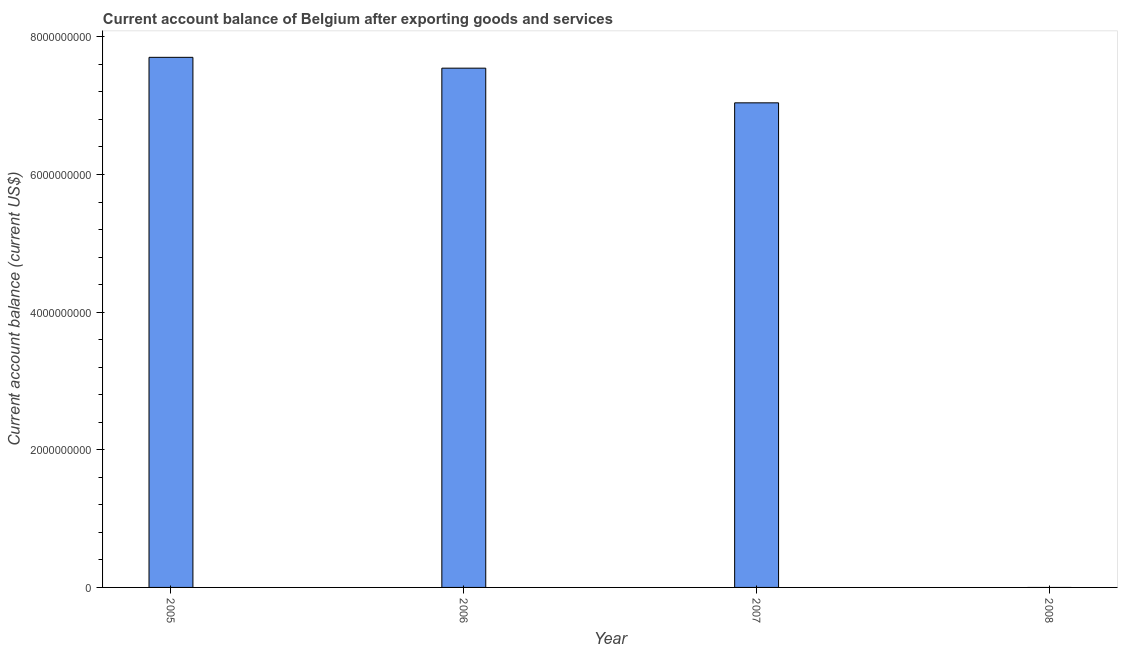Does the graph contain any zero values?
Your response must be concise. Yes. What is the title of the graph?
Offer a very short reply. Current account balance of Belgium after exporting goods and services. What is the label or title of the X-axis?
Ensure brevity in your answer.  Year. What is the label or title of the Y-axis?
Your answer should be compact. Current account balance (current US$). What is the current account balance in 2007?
Give a very brief answer. 7.04e+09. Across all years, what is the maximum current account balance?
Keep it short and to the point. 7.70e+09. Across all years, what is the minimum current account balance?
Ensure brevity in your answer.  0. In which year was the current account balance maximum?
Provide a short and direct response. 2005. What is the sum of the current account balance?
Your answer should be very brief. 2.23e+1. What is the difference between the current account balance in 2005 and 2007?
Your answer should be very brief. 6.61e+08. What is the average current account balance per year?
Your answer should be very brief. 5.57e+09. What is the median current account balance?
Keep it short and to the point. 7.29e+09. What is the ratio of the current account balance in 2006 to that in 2007?
Keep it short and to the point. 1.07. Is the difference between the current account balance in 2005 and 2006 greater than the difference between any two years?
Offer a very short reply. No. What is the difference between the highest and the second highest current account balance?
Provide a short and direct response. 1.58e+08. What is the difference between the highest and the lowest current account balance?
Your response must be concise. 7.70e+09. In how many years, is the current account balance greater than the average current account balance taken over all years?
Your answer should be compact. 3. How many bars are there?
Offer a terse response. 3. What is the difference between two consecutive major ticks on the Y-axis?
Offer a terse response. 2.00e+09. Are the values on the major ticks of Y-axis written in scientific E-notation?
Your answer should be very brief. No. What is the Current account balance (current US$) in 2005?
Provide a short and direct response. 7.70e+09. What is the Current account balance (current US$) of 2006?
Give a very brief answer. 7.55e+09. What is the Current account balance (current US$) in 2007?
Your response must be concise. 7.04e+09. What is the difference between the Current account balance (current US$) in 2005 and 2006?
Offer a very short reply. 1.58e+08. What is the difference between the Current account balance (current US$) in 2005 and 2007?
Give a very brief answer. 6.61e+08. What is the difference between the Current account balance (current US$) in 2006 and 2007?
Offer a very short reply. 5.04e+08. What is the ratio of the Current account balance (current US$) in 2005 to that in 2007?
Offer a terse response. 1.09. What is the ratio of the Current account balance (current US$) in 2006 to that in 2007?
Offer a very short reply. 1.07. 